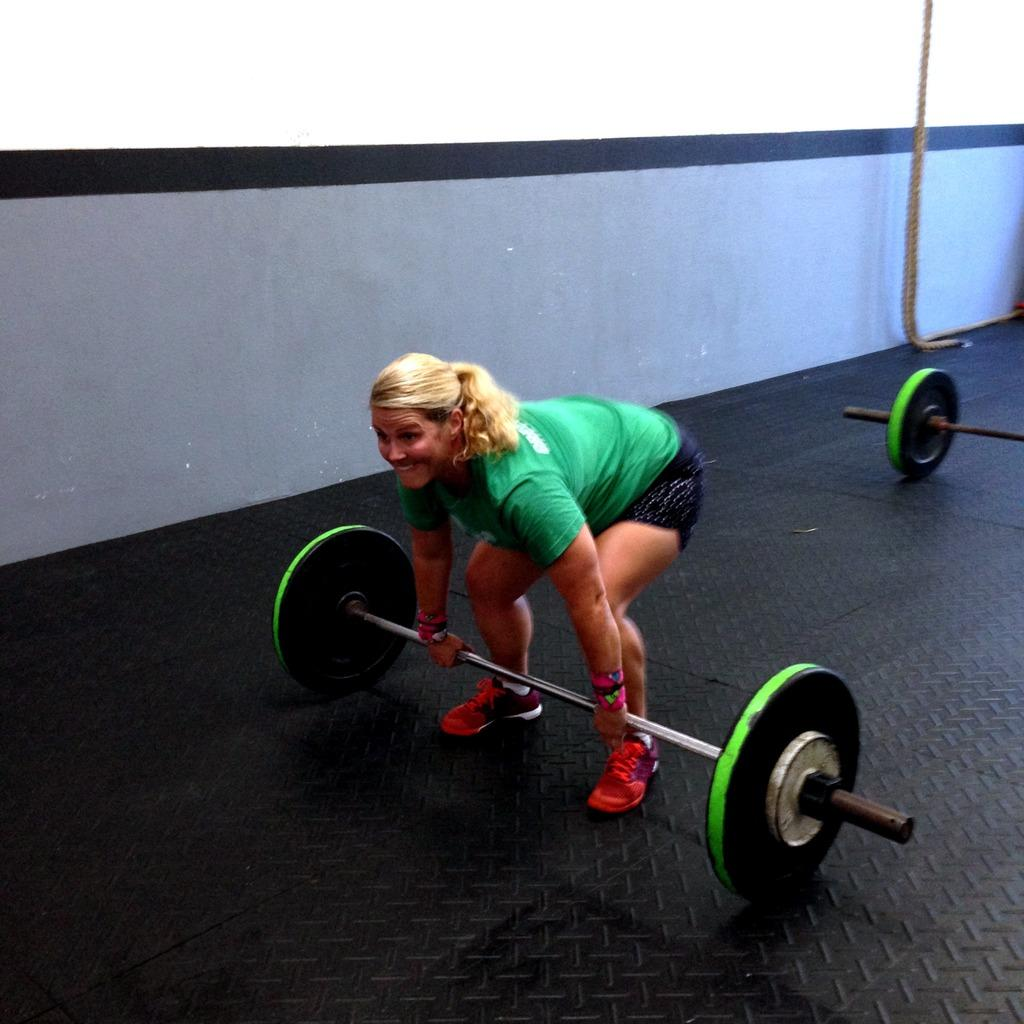Who is the main subject in the image? There is a woman in the image. What is the woman doing in the image? The woman is trying to lift weights. What type of cast is the woman wearing on her arm while lifting weights? There is no cast visible on the woman's arm in the image. What territory is the woman trying to conquer by lifting weights? The image does not depict any territorial conquest; it simply shows a woman lifting weights. 